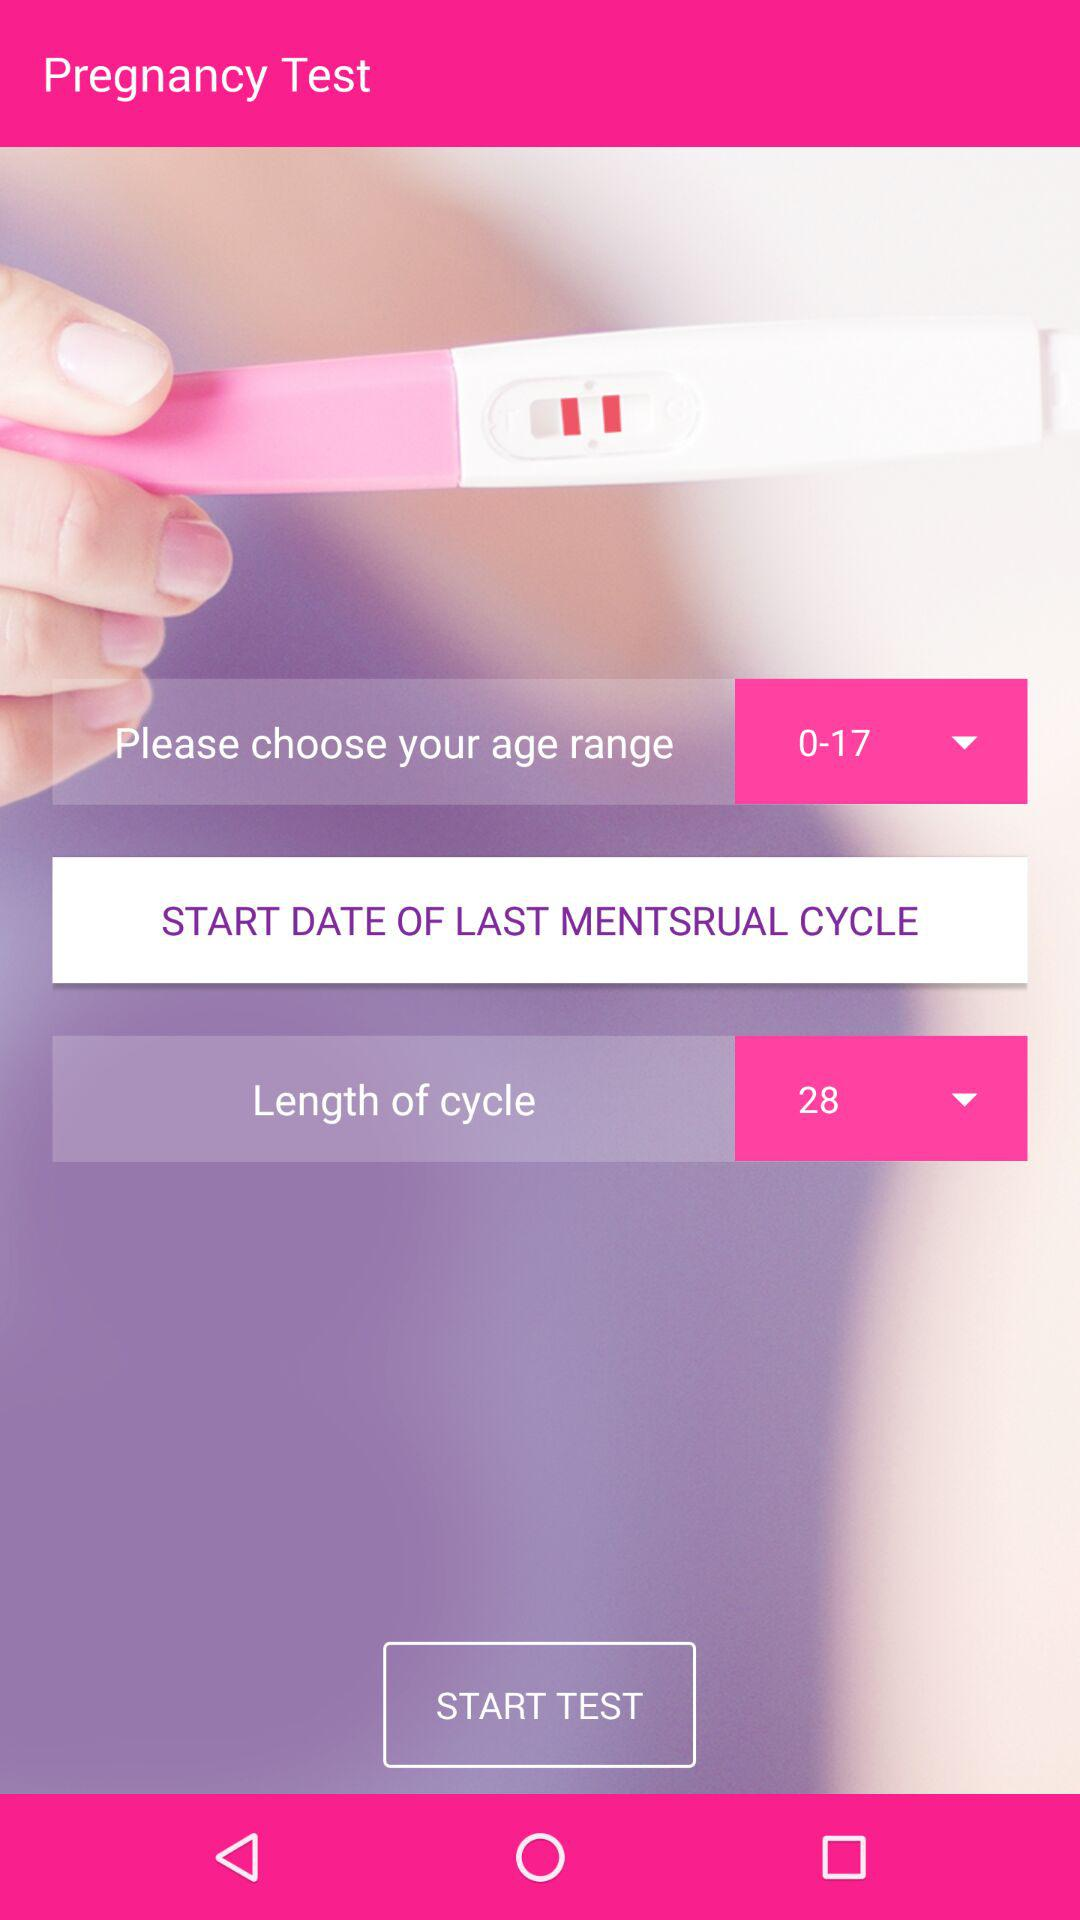What is the age range? The age range is from 0 to 17 years. 